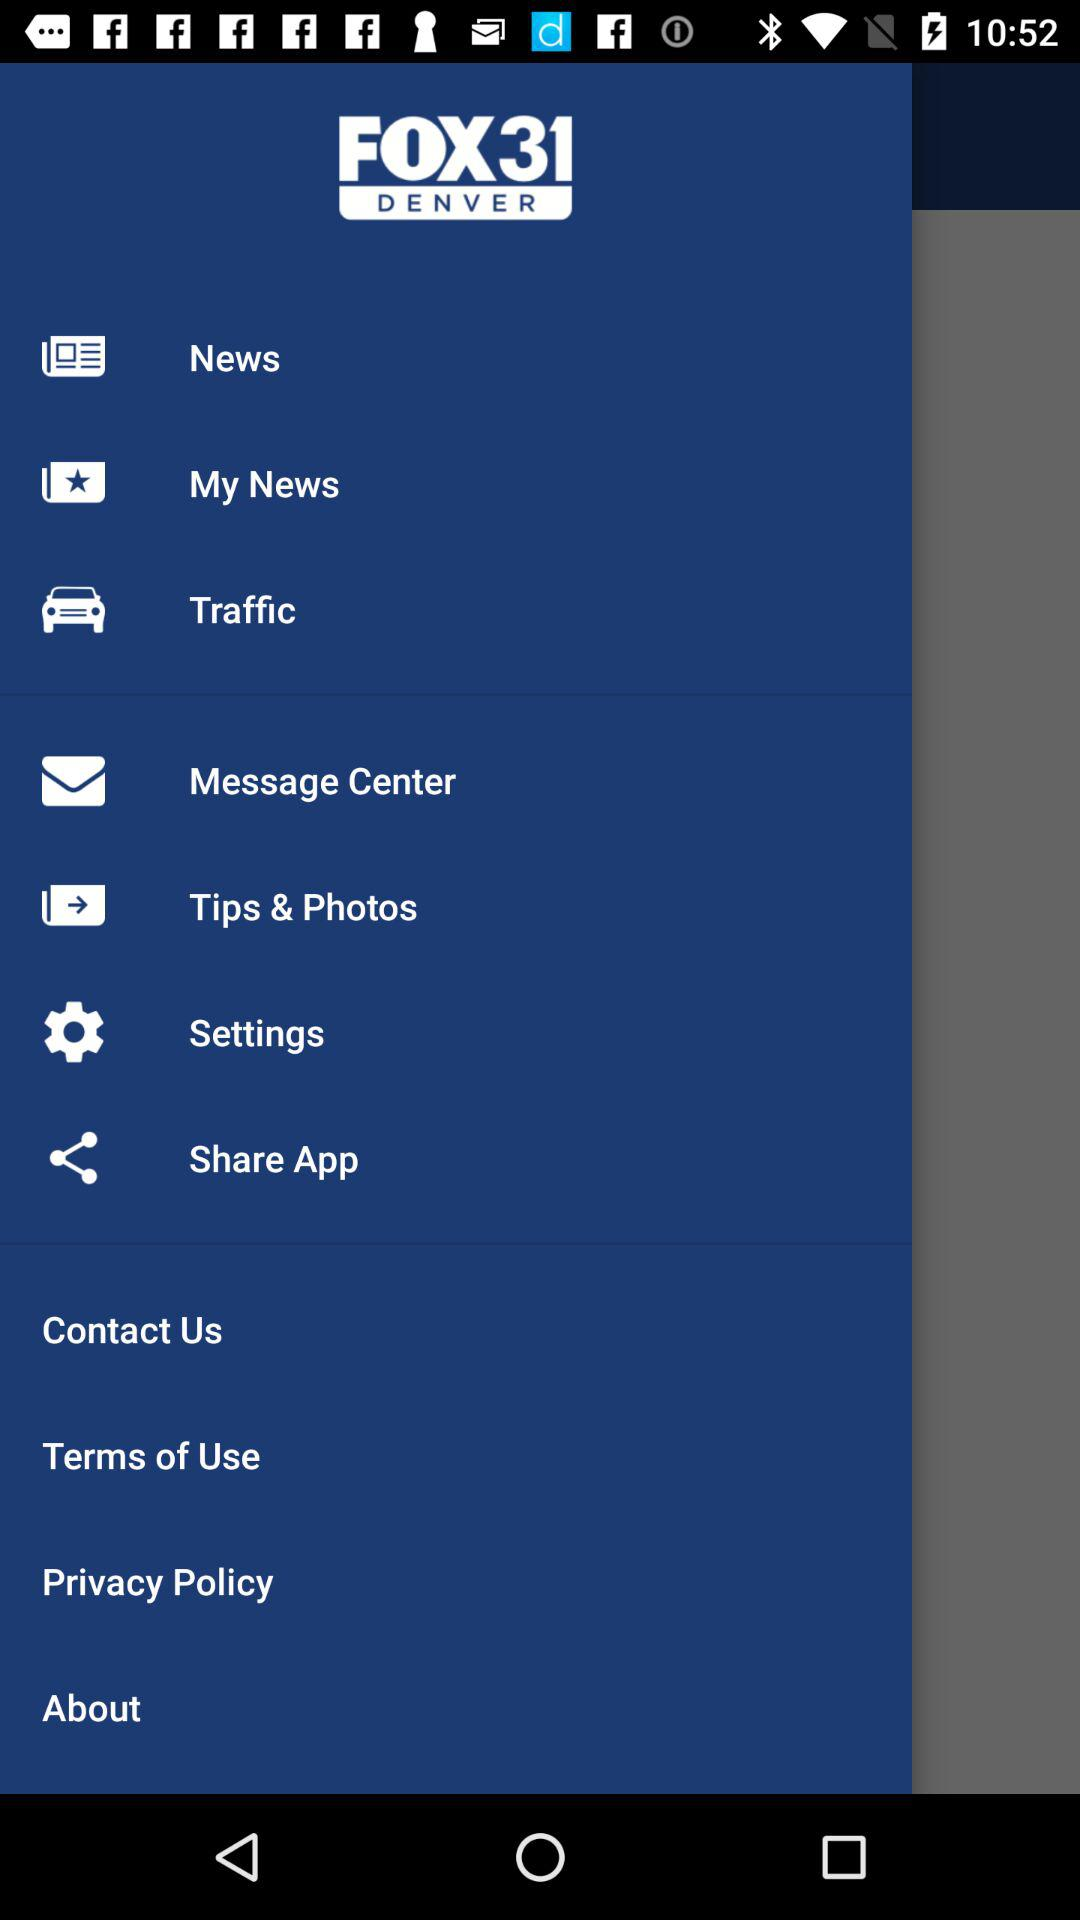What is the application name? The application name is "FOX31 DENVER". 